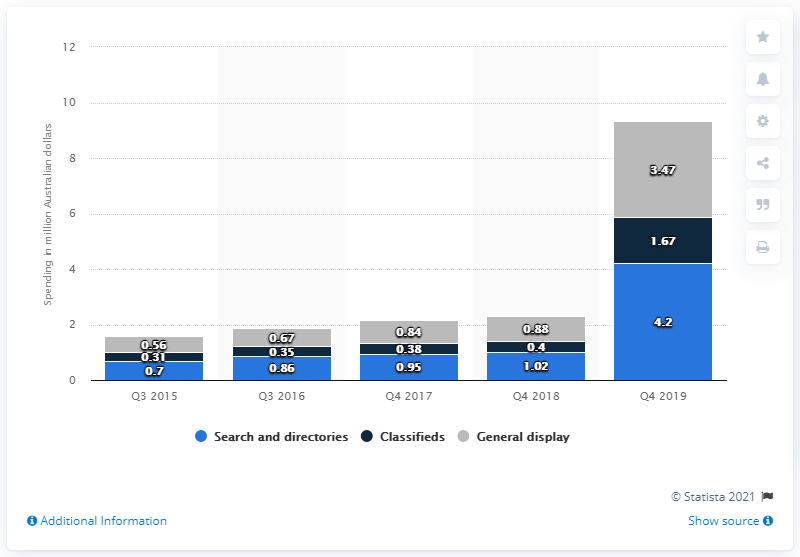Identify some key points in this picture. In 2019, a total of 1.67 Australian dollars was spent on classified ads. In 2019, a total of AUD 4.2 million was spent on search and directory advertising in Australia. 